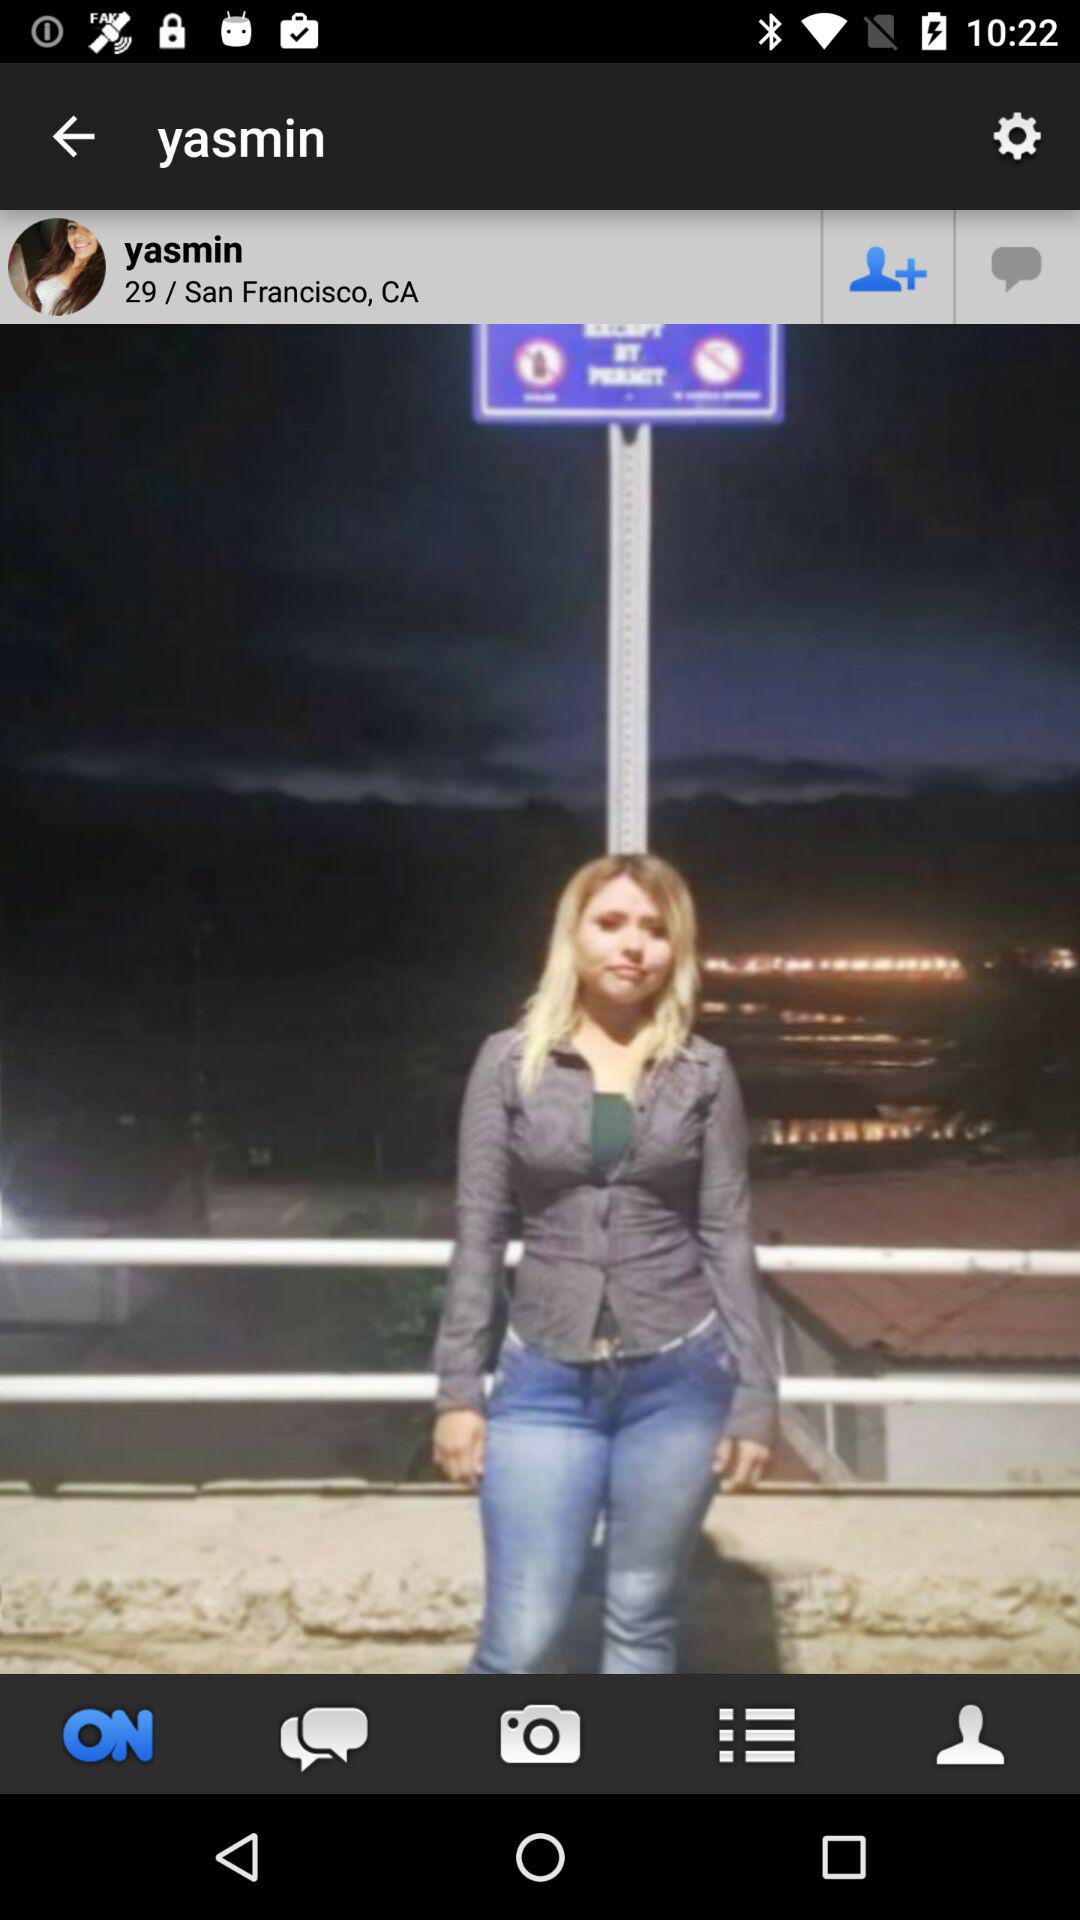What is the age given? The given age is 29. 